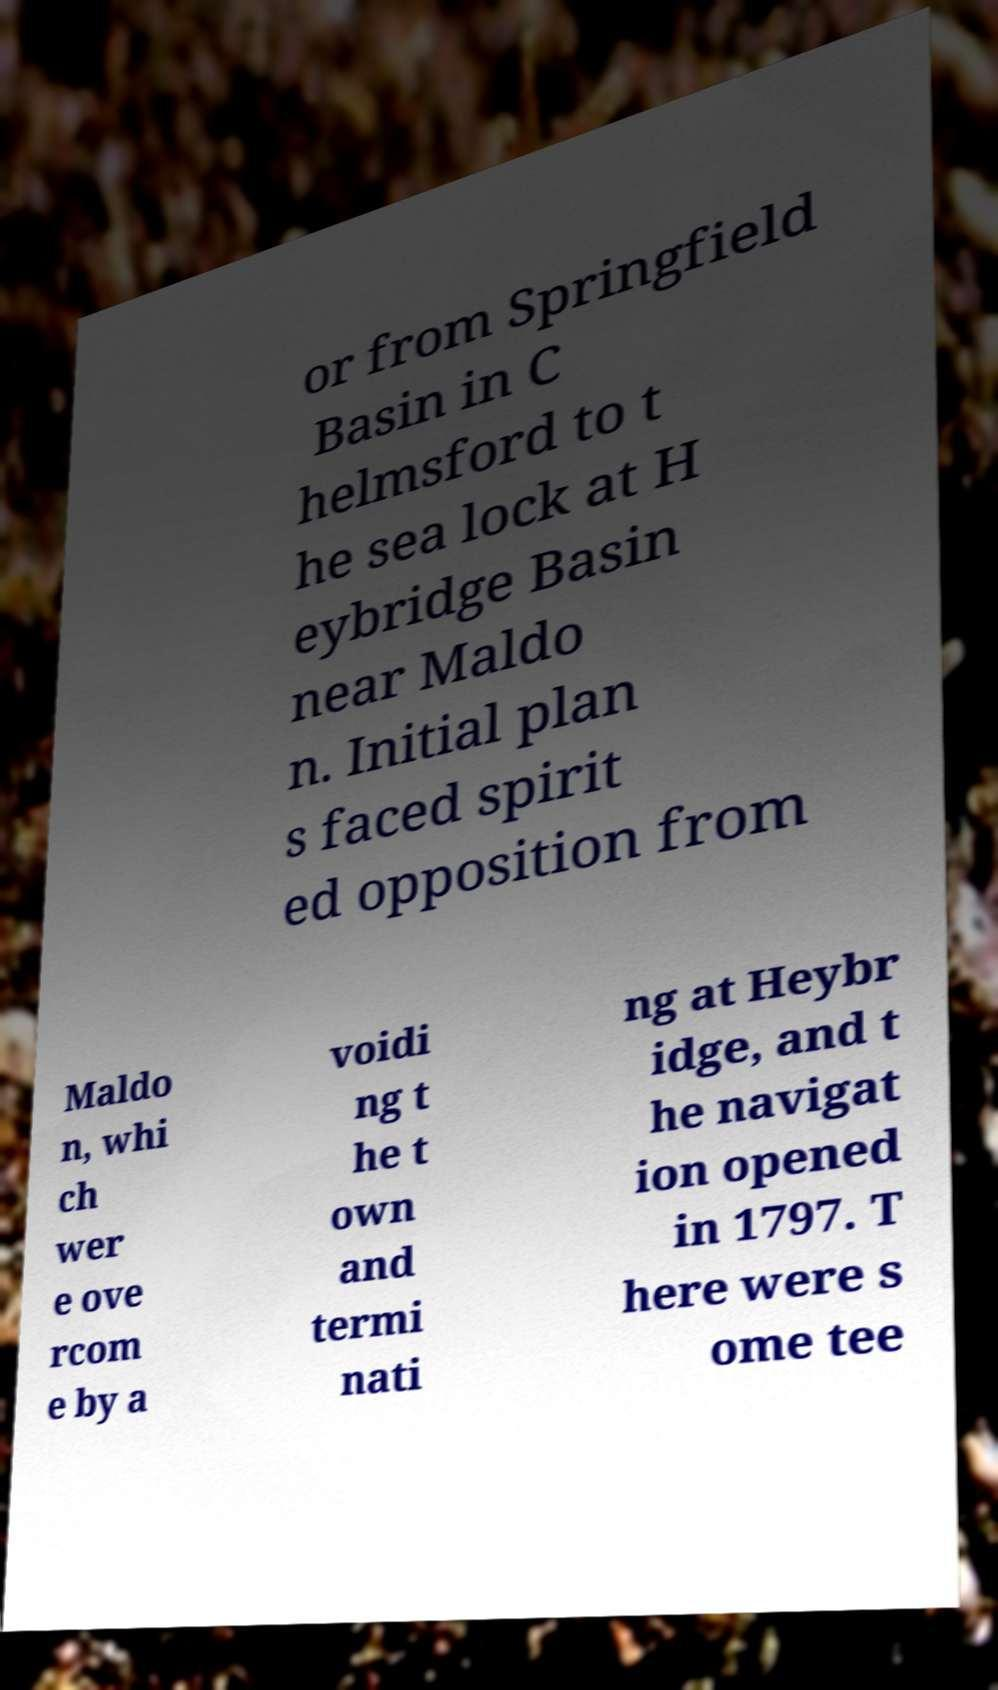For documentation purposes, I need the text within this image transcribed. Could you provide that? or from Springfield Basin in C helmsford to t he sea lock at H eybridge Basin near Maldo n. Initial plan s faced spirit ed opposition from Maldo n, whi ch wer e ove rcom e by a voidi ng t he t own and termi nati ng at Heybr idge, and t he navigat ion opened in 1797. T here were s ome tee 